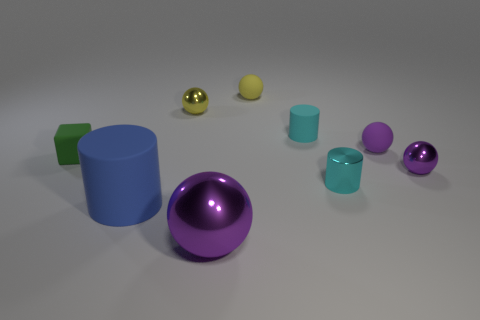There is a purple thing in front of the small purple metal ball; how big is it?
Your response must be concise. Large. What is the large blue cylinder made of?
Provide a succinct answer. Rubber. Is the shape of the yellow object on the left side of the big purple metallic sphere the same as  the small purple metal object?
Your response must be concise. Yes. What size is the matte cylinder that is the same color as the small shiny cylinder?
Provide a succinct answer. Small. Is there a yellow sphere that has the same size as the blue rubber object?
Offer a terse response. No. There is a purple metal sphere in front of the matte thing in front of the small green thing; is there a shiny thing that is behind it?
Provide a succinct answer. Yes. Is the color of the tiny metallic cylinder the same as the tiny rubber thing that is to the left of the big rubber thing?
Your answer should be very brief. No. What is the material of the purple object in front of the purple metallic thing behind the rubber cylinder on the left side of the big ball?
Your response must be concise. Metal. There is a object in front of the big rubber cylinder; what shape is it?
Make the answer very short. Sphere. There is a yellow sphere that is made of the same material as the large blue thing; what size is it?
Provide a short and direct response. Small. 